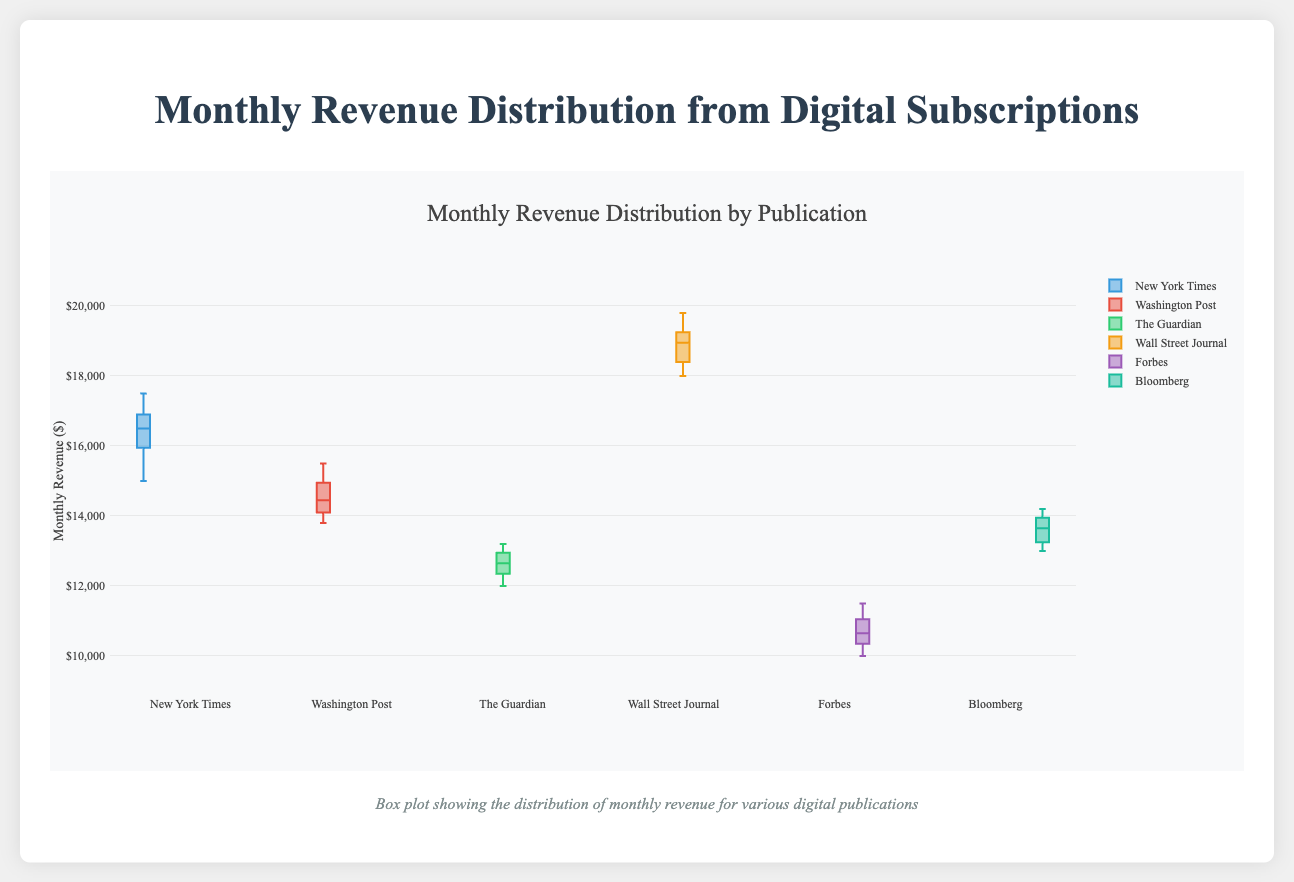What is the title of the figure? The title can be found at the top of the plot.
Answer: Monthly Revenue Distribution by Publication What is the highest revenue recorded for the Wall Street Journal? The highest revenue for the Wall Street Journal can be observed by looking at the upper extremity of its box plot.
Answer: $19800 Which publication has the lowest median monthly revenue? The median can be found in the middle of the box plot where the bar is located. Compare the medians of all publications to find the lowest one.
Answer: Forbes Between which two values does the interquartile range (IQR) of the New York Times' revenue lie? The IQR is represented by the box of the box plot. The lower bound of the box is Q1 and the upper bound is Q3. Refer to the New York Times box plot for this information.
Answer: $15900 and $17000 How does the median revenue of Washington Post compare to that of the Guardian? To compare the medians, look at the middle bars of the box plots for Washington Post and the Guardian.
Answer: Washington Post is higher Which two publications have the most similar revenue distributions, based on the spread of their interquartile ranges? The IQR spread can be compared by looking at the lengths of the boxes. Find the two boxes of similar lengths.
Answer: Washington Post and Bloomberg What color represents Forbes in the plot? Each publication is represented by a different color in the plot. Identify the color associated with Forbes by comparing the color bars.
Answer: Purple What is the range of monthly revenue for Bloomberg? The range is found by subtracting the minimum value from the maximum value in Bloomberg’s box plot. This can be observed from the extremities of the whiskers.
Answer: $13000 to $14200 Are there any outliers in the revenue distribution for the New York Times? Outliers can be identified by points outside the whiskers of the box plot. Check the New York Times box plot for any such points.
Answer: No How does the revenue variability of the Wall Street Journal compare to the Forbes? Revenue variability can be assessed by comparing the lengths of their box plots (IQR) and whiskers. Larger variability will have a longer IQR and whiskers.
Answer: Wall Street Journal has higher variability 